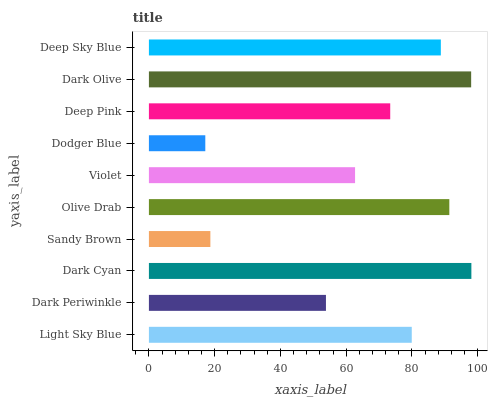Is Dodger Blue the minimum?
Answer yes or no. Yes. Is Dark Cyan the maximum?
Answer yes or no. Yes. Is Dark Periwinkle the minimum?
Answer yes or no. No. Is Dark Periwinkle the maximum?
Answer yes or no. No. Is Light Sky Blue greater than Dark Periwinkle?
Answer yes or no. Yes. Is Dark Periwinkle less than Light Sky Blue?
Answer yes or no. Yes. Is Dark Periwinkle greater than Light Sky Blue?
Answer yes or no. No. Is Light Sky Blue less than Dark Periwinkle?
Answer yes or no. No. Is Light Sky Blue the high median?
Answer yes or no. Yes. Is Deep Pink the low median?
Answer yes or no. Yes. Is Olive Drab the high median?
Answer yes or no. No. Is Dodger Blue the low median?
Answer yes or no. No. 